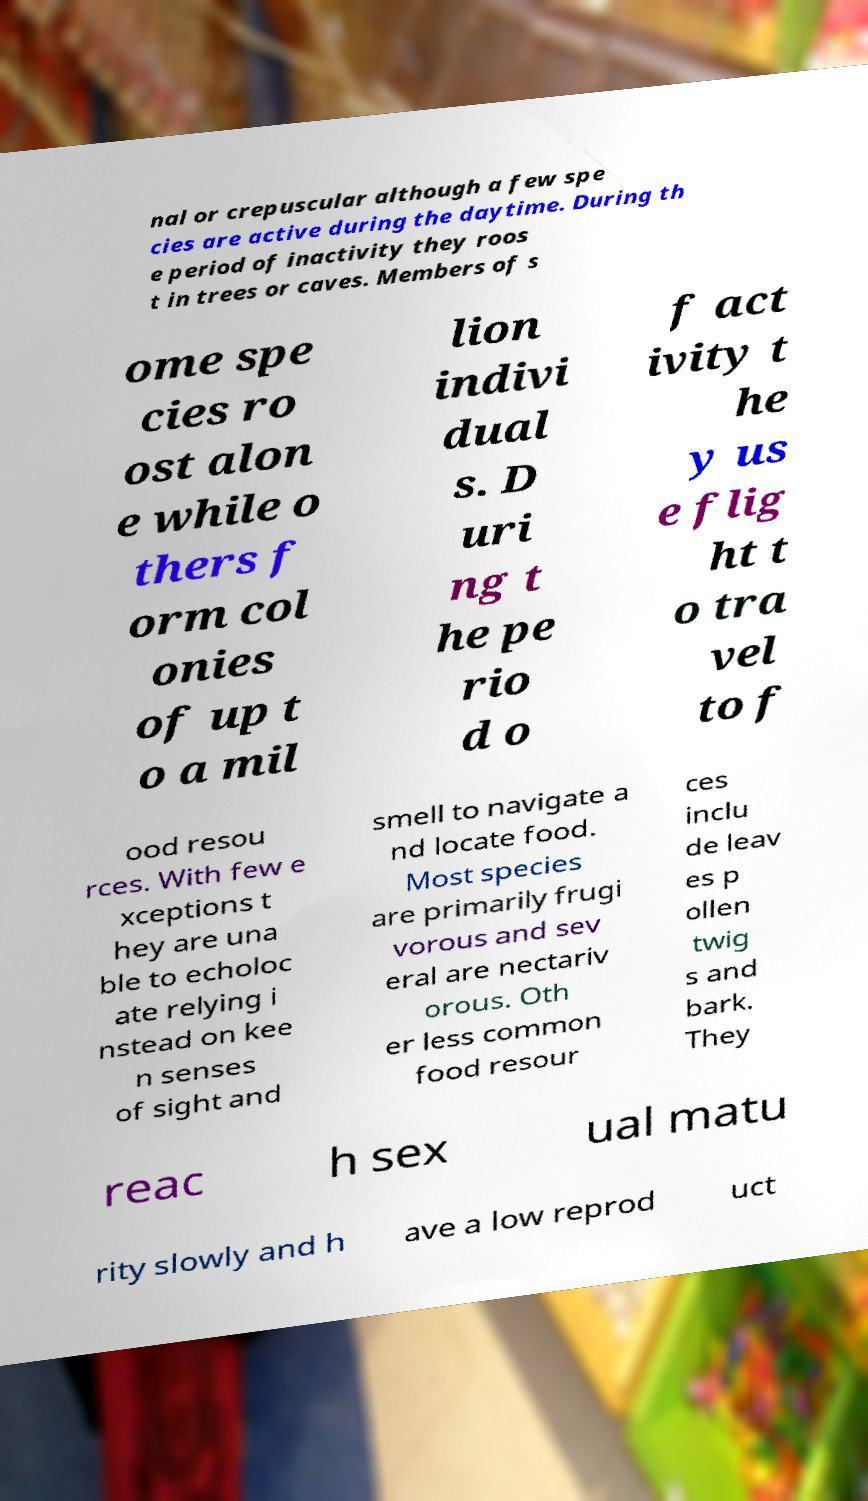Could you extract and type out the text from this image? nal or crepuscular although a few spe cies are active during the daytime. During th e period of inactivity they roos t in trees or caves. Members of s ome spe cies ro ost alon e while o thers f orm col onies of up t o a mil lion indivi dual s. D uri ng t he pe rio d o f act ivity t he y us e flig ht t o tra vel to f ood resou rces. With few e xceptions t hey are una ble to echoloc ate relying i nstead on kee n senses of sight and smell to navigate a nd locate food. Most species are primarily frugi vorous and sev eral are nectariv orous. Oth er less common food resour ces inclu de leav es p ollen twig s and bark. They reac h sex ual matu rity slowly and h ave a low reprod uct 